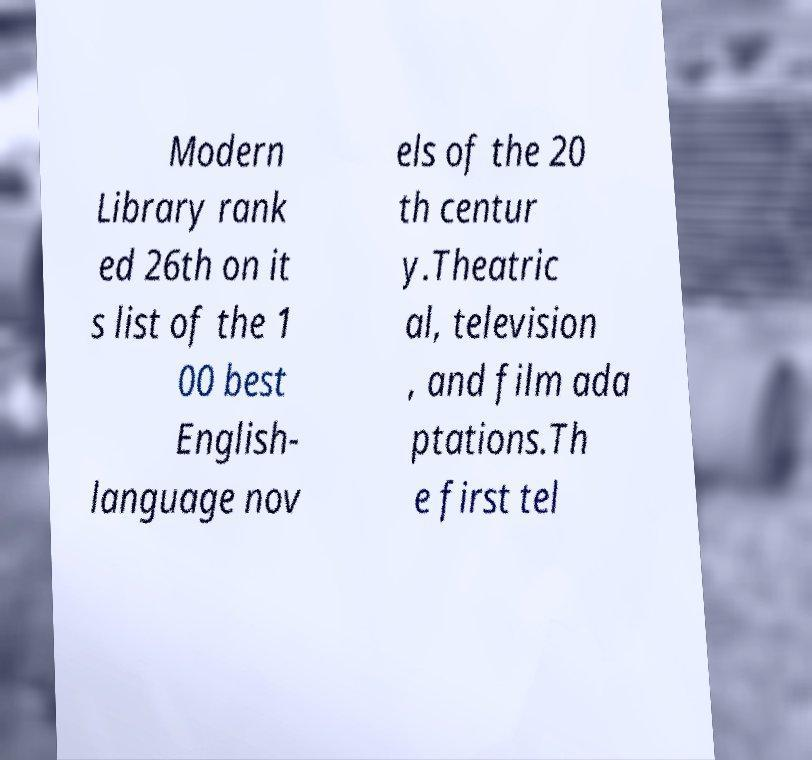Could you assist in decoding the text presented in this image and type it out clearly? Modern Library rank ed 26th on it s list of the 1 00 best English- language nov els of the 20 th centur y.Theatric al, television , and film ada ptations.Th e first tel 